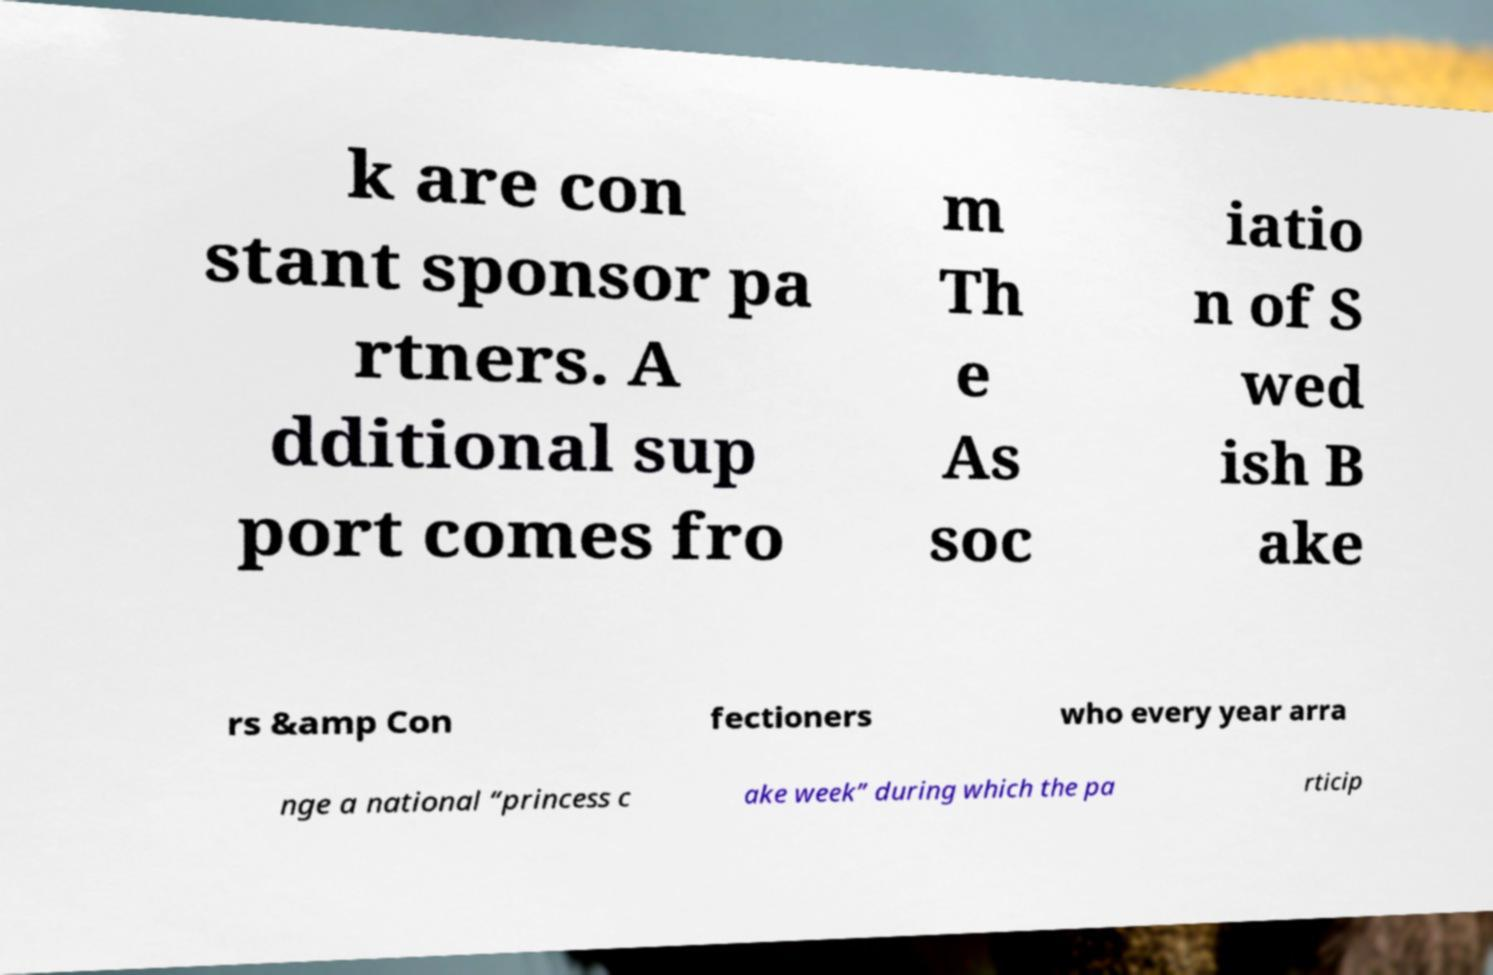Could you extract and type out the text from this image? k are con stant sponsor pa rtners. A dditional sup port comes fro m Th e As soc iatio n of S wed ish B ake rs &amp Con fectioners who every year arra nge a national “princess c ake week” during which the pa rticip 